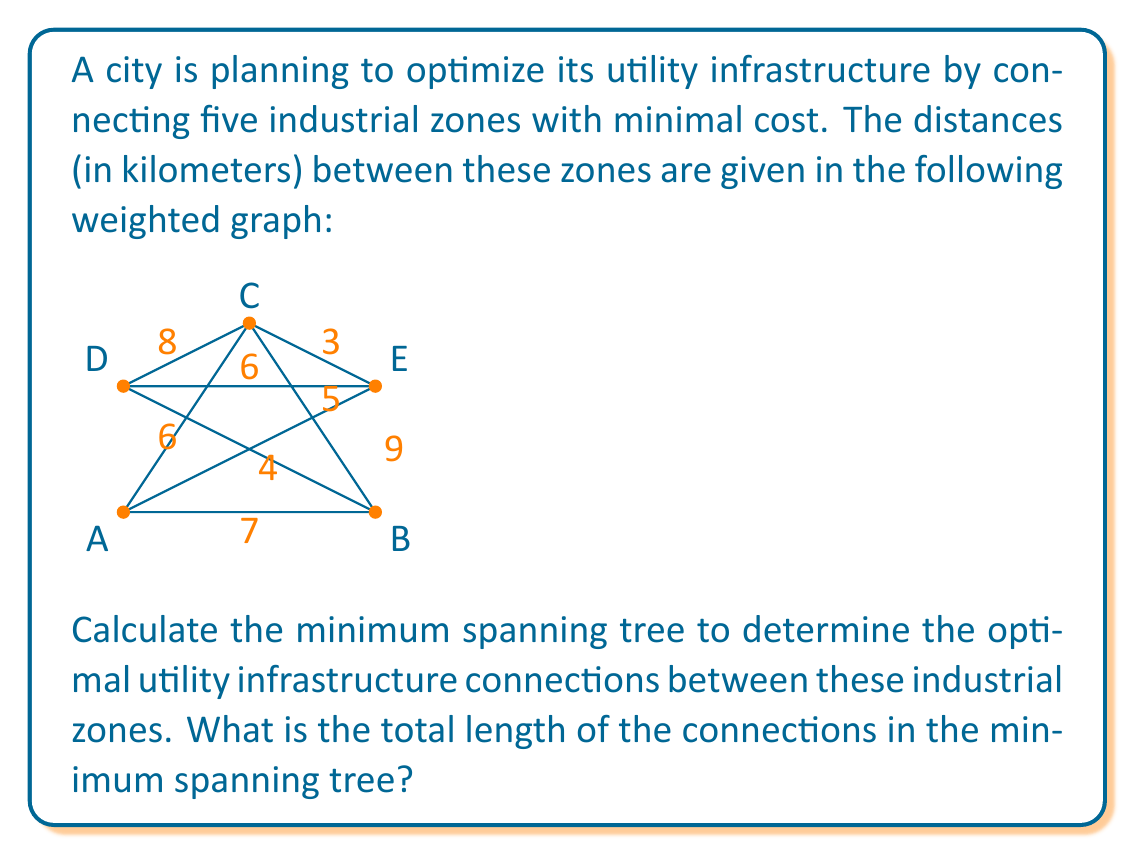What is the answer to this math problem? To solve this problem, we'll use Kruskal's algorithm to find the minimum spanning tree (MST). Here are the steps:

1) First, list all edges in ascending order of weight:
   C-E: 3
   B-D: 4
   B-C: 5
   A-C: 6
   D-E: 6
   A-B: 7
   C-D: 8
   A-E: 9

2) Start with an empty graph and add edges one by one, avoiding cycles:

   - Add C-E (3)
   - Add B-D (4)
   - Add B-C (5)
   - Add A-C (6)

3) At this point, we have added 4 edges, which is enough to connect all 5 vertices (n-1 edges, where n is the number of vertices). The MST is complete.

The resulting minimum spanning tree looks like this:

[asy]
unitsize(1cm);

pair A = (0,0);
pair B = (4,0);
pair C = (2,3);
pair D = (0,2);
pair E = (4,2);

draw(A--C, blue+1);
draw(B--C, blue+1);
draw(B--D, blue+1);
draw(C--E, blue+1);

dot("A", A, SW);
dot("B", B, SE);
dot("C", C, N);
dot("D", D, NW);
dot("E", E, NE);

label("6", (A+C)/2, NW);
label("5", (B+C)/2, SE);
label("4", (B+D)/2, NE);
label("3", (C+E)/2, NE);
[/asy]

4) To calculate the total length, sum the weights of the edges in the MST:

   $$ \text{Total length} = 3 + 4 + 5 + 6 = 18 \text{ km} $$
Answer: The total length of the connections in the minimum spanning tree is 18 km. 